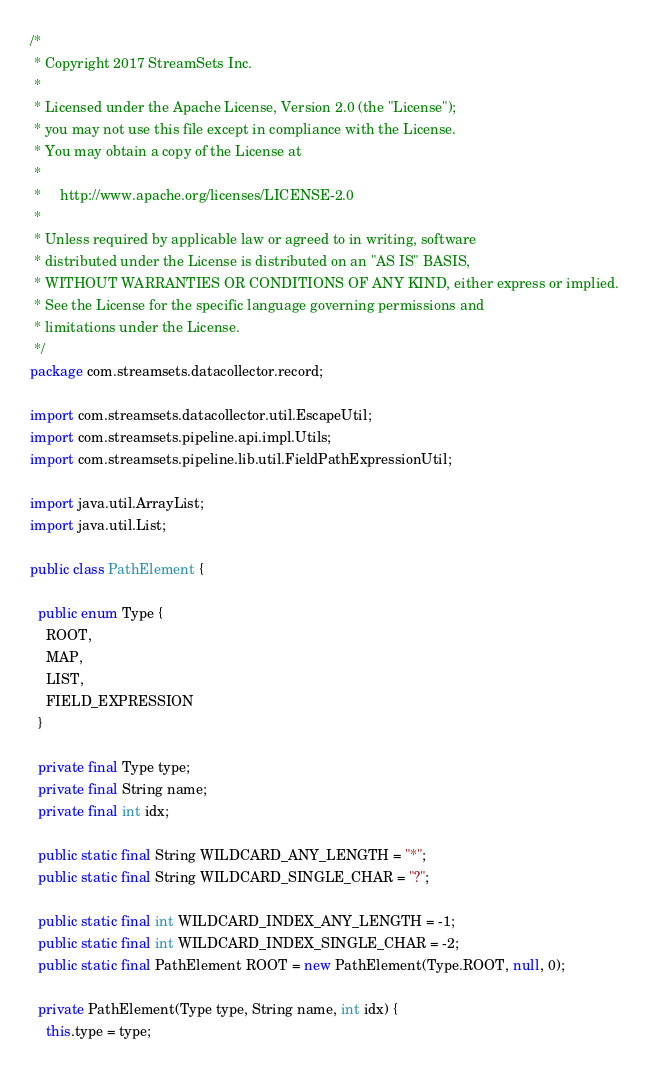Convert code to text. <code><loc_0><loc_0><loc_500><loc_500><_Java_>/*
 * Copyright 2017 StreamSets Inc.
 *
 * Licensed under the Apache License, Version 2.0 (the "License");
 * you may not use this file except in compliance with the License.
 * You may obtain a copy of the License at
 *
 *     http://www.apache.org/licenses/LICENSE-2.0
 *
 * Unless required by applicable law or agreed to in writing, software
 * distributed under the License is distributed on an "AS IS" BASIS,
 * WITHOUT WARRANTIES OR CONDITIONS OF ANY KIND, either express or implied.
 * See the License for the specific language governing permissions and
 * limitations under the License.
 */
package com.streamsets.datacollector.record;

import com.streamsets.datacollector.util.EscapeUtil;
import com.streamsets.pipeline.api.impl.Utils;
import com.streamsets.pipeline.lib.util.FieldPathExpressionUtil;

import java.util.ArrayList;
import java.util.List;

public class PathElement {

  public enum Type {
    ROOT,
    MAP,
    LIST,
    FIELD_EXPRESSION
  }

  private final Type type;
  private final String name;
  private final int idx;

  public static final String WILDCARD_ANY_LENGTH = "*";
  public static final String WILDCARD_SINGLE_CHAR = "?";

  public static final int WILDCARD_INDEX_ANY_LENGTH = -1;
  public static final int WILDCARD_INDEX_SINGLE_CHAR = -2;
  public static final PathElement ROOT = new PathElement(Type.ROOT, null, 0);

  private PathElement(Type type, String name, int idx) {
    this.type = type;</code> 